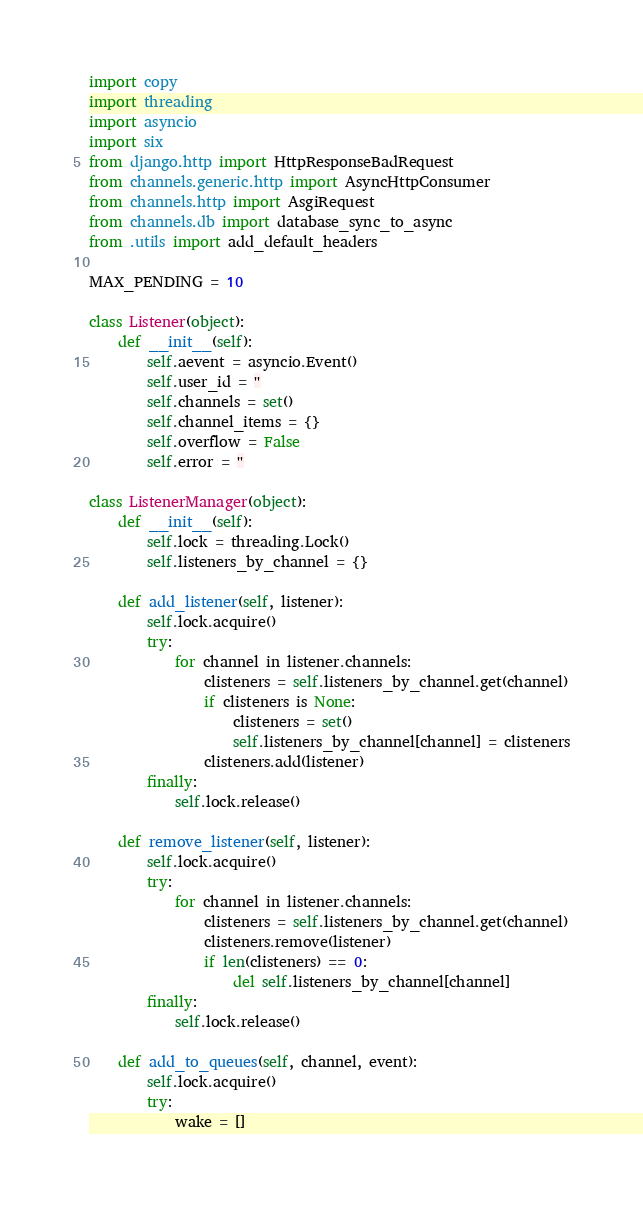Convert code to text. <code><loc_0><loc_0><loc_500><loc_500><_Python_>import copy
import threading
import asyncio
import six
from django.http import HttpResponseBadRequest
from channels.generic.http import AsyncHttpConsumer
from channels.http import AsgiRequest
from channels.db import database_sync_to_async
from .utils import add_default_headers

MAX_PENDING = 10

class Listener(object):
	def __init__(self):
		self.aevent = asyncio.Event()
		self.user_id = ''
		self.channels = set()
		self.channel_items = {}
		self.overflow = False
		self.error = ''

class ListenerManager(object):
	def __init__(self):
		self.lock = threading.Lock()
		self.listeners_by_channel = {}

	def add_listener(self, listener):
		self.lock.acquire()
		try:
			for channel in listener.channels:
				clisteners = self.listeners_by_channel.get(channel)
				if clisteners is None:
					clisteners = set()
					self.listeners_by_channel[channel] = clisteners
				clisteners.add(listener)
		finally:
			self.lock.release()

	def remove_listener(self, listener):
		self.lock.acquire()
		try:
			for channel in listener.channels:
				clisteners = self.listeners_by_channel.get(channel)
				clisteners.remove(listener)
				if len(clisteners) == 0:
					del self.listeners_by_channel[channel]
		finally:
			self.lock.release()

	def add_to_queues(self, channel, event):
		self.lock.acquire()
		try:
			wake = []</code> 